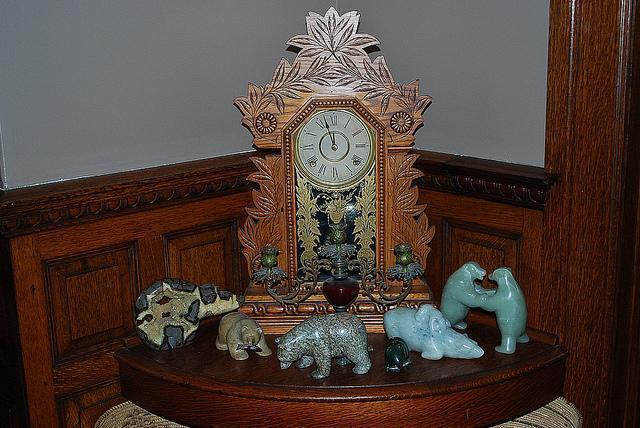What material are the two bears to the right of the desk clock made from?
From the following set of four choices, select the accurate answer to respond to the question.
Options: Glass, plastic, jade, ceramic. Jade. 